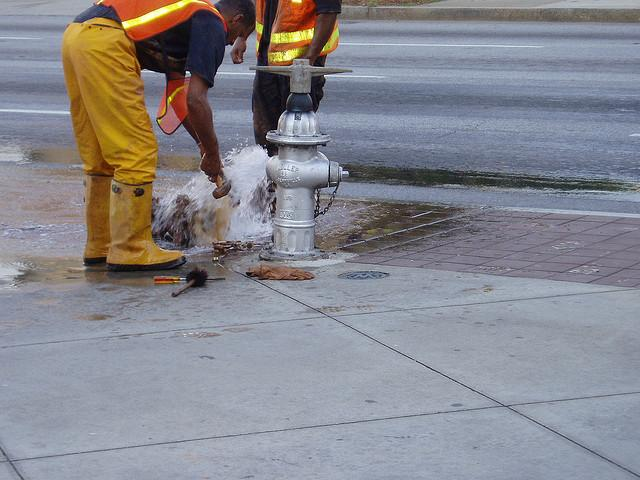Who is paying the person with the hammer? city 